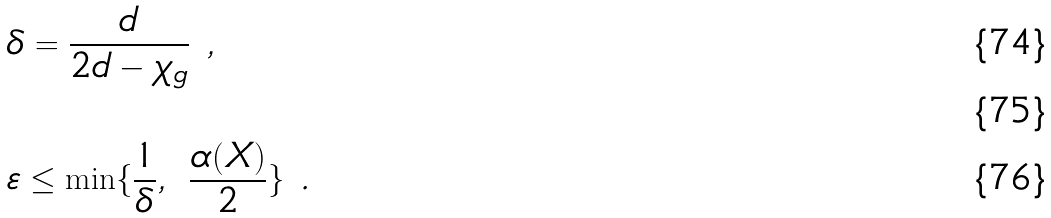<formula> <loc_0><loc_0><loc_500><loc_500>& \delta = \frac { d } { 2 d - \chi _ { g } } \ , \\ \ \\ & \varepsilon \leq \min \{ \frac { 1 } { \delta } , \ \frac { \alpha ( X ) } { 2 } \} \ .</formula> 